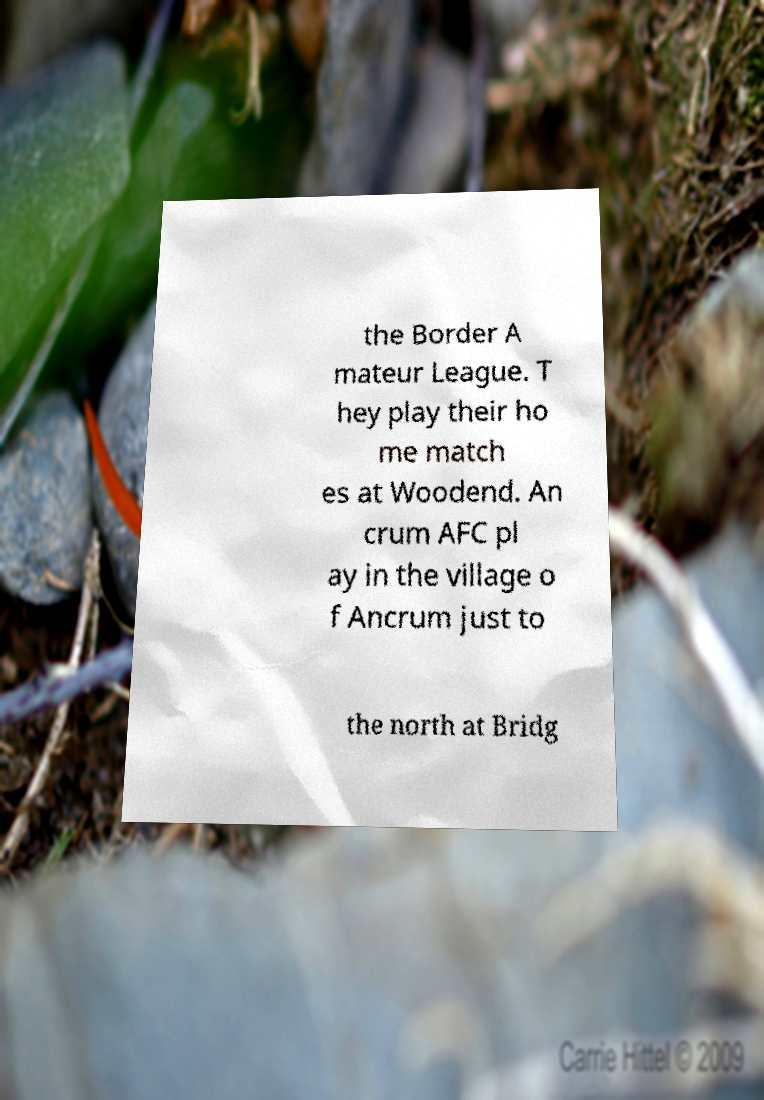For documentation purposes, I need the text within this image transcribed. Could you provide that? the Border A mateur League. T hey play their ho me match es at Woodend. An crum AFC pl ay in the village o f Ancrum just to the north at Bridg 